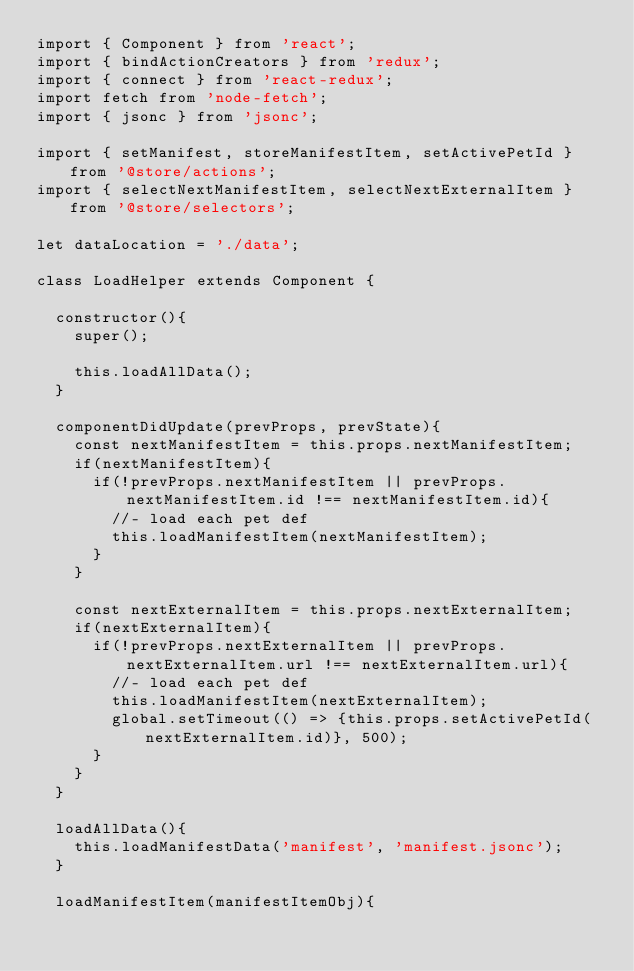<code> <loc_0><loc_0><loc_500><loc_500><_JavaScript_>import { Component } from 'react';
import { bindActionCreators } from 'redux';
import { connect } from 'react-redux';
import fetch from 'node-fetch';
import { jsonc } from 'jsonc';

import { setManifest, storeManifestItem, setActivePetId } from '@store/actions';
import { selectNextManifestItem, selectNextExternalItem } from '@store/selectors';

let dataLocation = './data';

class LoadHelper extends Component {

  constructor(){
    super();

    this.loadAllData();
  }

  componentDidUpdate(prevProps, prevState){
    const nextManifestItem = this.props.nextManifestItem;
    if(nextManifestItem){
      if(!prevProps.nextManifestItem || prevProps.nextManifestItem.id !== nextManifestItem.id){
        //- load each pet def
        this.loadManifestItem(nextManifestItem);
      }
    }
    
    const nextExternalItem = this.props.nextExternalItem;
    if(nextExternalItem){
      if(!prevProps.nextExternalItem || prevProps.nextExternalItem.url !== nextExternalItem.url){
        //- load each pet def
        this.loadManifestItem(nextExternalItem);
        global.setTimeout(() => {this.props.setActivePetId(nextExternalItem.id)}, 500);
      }
    }
  }

  loadAllData(){
    this.loadManifestData('manifest', 'manifest.jsonc');
  }

  loadManifestItem(manifestItemObj){</code> 